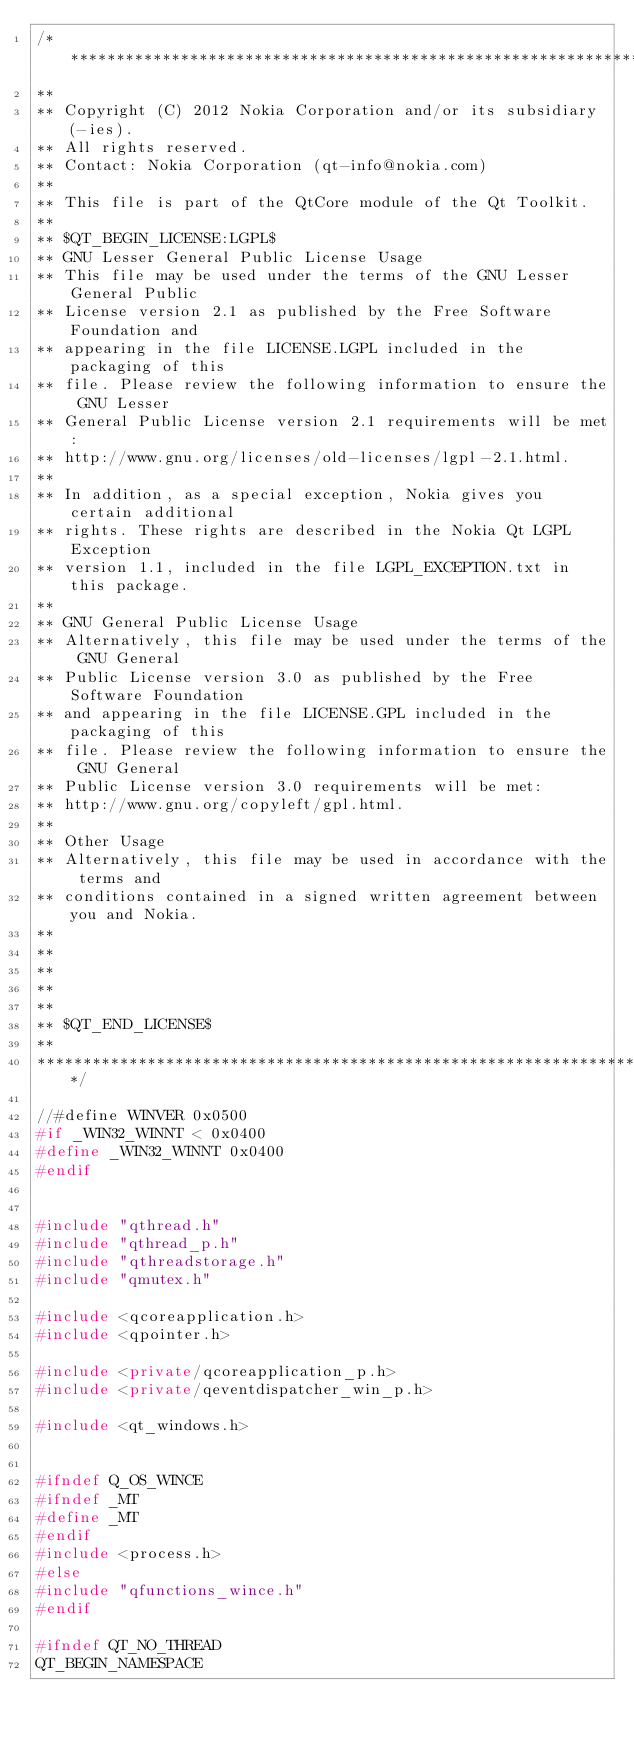<code> <loc_0><loc_0><loc_500><loc_500><_C++_>/****************************************************************************
**
** Copyright (C) 2012 Nokia Corporation and/or its subsidiary(-ies).
** All rights reserved.
** Contact: Nokia Corporation (qt-info@nokia.com)
**
** This file is part of the QtCore module of the Qt Toolkit.
**
** $QT_BEGIN_LICENSE:LGPL$
** GNU Lesser General Public License Usage
** This file may be used under the terms of the GNU Lesser General Public
** License version 2.1 as published by the Free Software Foundation and
** appearing in the file LICENSE.LGPL included in the packaging of this
** file. Please review the following information to ensure the GNU Lesser
** General Public License version 2.1 requirements will be met:
** http://www.gnu.org/licenses/old-licenses/lgpl-2.1.html.
**
** In addition, as a special exception, Nokia gives you certain additional
** rights. These rights are described in the Nokia Qt LGPL Exception
** version 1.1, included in the file LGPL_EXCEPTION.txt in this package.
**
** GNU General Public License Usage
** Alternatively, this file may be used under the terms of the GNU General
** Public License version 3.0 as published by the Free Software Foundation
** and appearing in the file LICENSE.GPL included in the packaging of this
** file. Please review the following information to ensure the GNU General
** Public License version 3.0 requirements will be met:
** http://www.gnu.org/copyleft/gpl.html.
**
** Other Usage
** Alternatively, this file may be used in accordance with the terms and
** conditions contained in a signed written agreement between you and Nokia.
**
**
**
**
**
** $QT_END_LICENSE$
**
****************************************************************************/

//#define WINVER 0x0500
#if _WIN32_WINNT < 0x0400
#define _WIN32_WINNT 0x0400
#endif


#include "qthread.h"
#include "qthread_p.h"
#include "qthreadstorage.h"
#include "qmutex.h"

#include <qcoreapplication.h>
#include <qpointer.h>

#include <private/qcoreapplication_p.h>
#include <private/qeventdispatcher_win_p.h>

#include <qt_windows.h>


#ifndef Q_OS_WINCE
#ifndef _MT
#define _MT
#endif
#include <process.h>
#else
#include "qfunctions_wince.h"
#endif

#ifndef QT_NO_THREAD
QT_BEGIN_NAMESPACE
</code> 